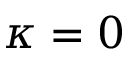Convert formula to latex. <formula><loc_0><loc_0><loc_500><loc_500>\kappa = 0</formula> 